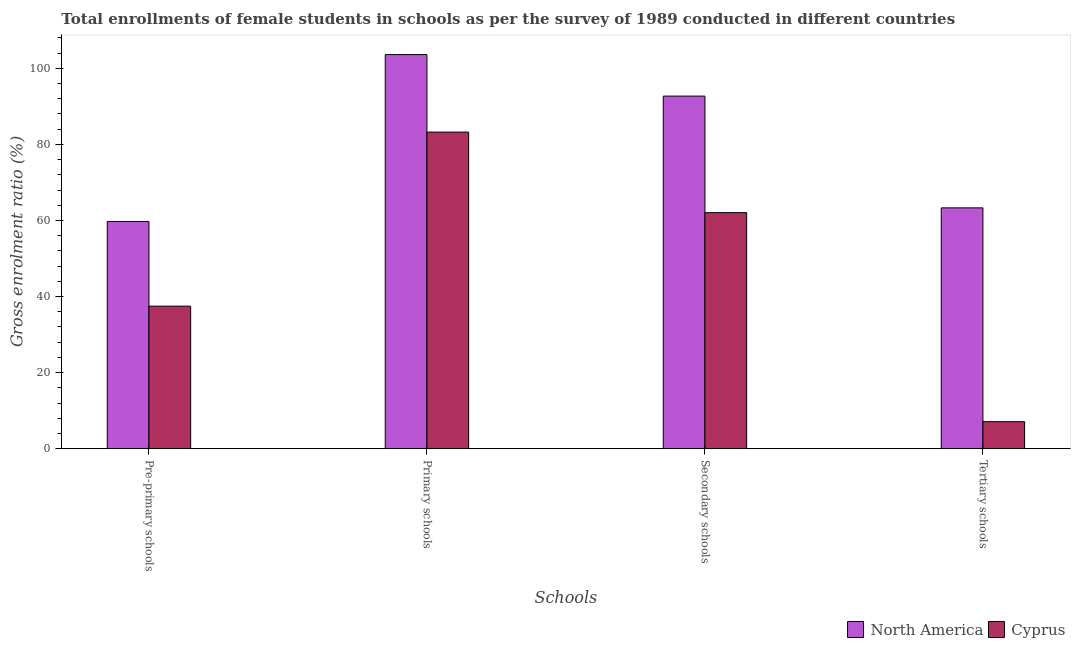How many groups of bars are there?
Ensure brevity in your answer.  4. Are the number of bars per tick equal to the number of legend labels?
Your response must be concise. Yes. How many bars are there on the 1st tick from the right?
Make the answer very short. 2. What is the label of the 3rd group of bars from the left?
Give a very brief answer. Secondary schools. What is the gross enrolment ratio(female) in pre-primary schools in Cyprus?
Your response must be concise. 37.47. Across all countries, what is the maximum gross enrolment ratio(female) in pre-primary schools?
Offer a terse response. 59.72. Across all countries, what is the minimum gross enrolment ratio(female) in tertiary schools?
Your response must be concise. 7.1. In which country was the gross enrolment ratio(female) in secondary schools minimum?
Offer a very short reply. Cyprus. What is the total gross enrolment ratio(female) in primary schools in the graph?
Provide a short and direct response. 186.83. What is the difference between the gross enrolment ratio(female) in primary schools in Cyprus and that in North America?
Offer a very short reply. -20.38. What is the difference between the gross enrolment ratio(female) in tertiary schools in Cyprus and the gross enrolment ratio(female) in secondary schools in North America?
Make the answer very short. -85.59. What is the average gross enrolment ratio(female) in secondary schools per country?
Make the answer very short. 77.37. What is the difference between the gross enrolment ratio(female) in secondary schools and gross enrolment ratio(female) in pre-primary schools in Cyprus?
Your answer should be compact. 24.58. In how many countries, is the gross enrolment ratio(female) in primary schools greater than 4 %?
Keep it short and to the point. 2. What is the ratio of the gross enrolment ratio(female) in secondary schools in Cyprus to that in North America?
Make the answer very short. 0.67. Is the gross enrolment ratio(female) in secondary schools in Cyprus less than that in North America?
Provide a short and direct response. Yes. Is the difference between the gross enrolment ratio(female) in pre-primary schools in Cyprus and North America greater than the difference between the gross enrolment ratio(female) in tertiary schools in Cyprus and North America?
Give a very brief answer. Yes. What is the difference between the highest and the second highest gross enrolment ratio(female) in secondary schools?
Provide a succinct answer. 30.64. What is the difference between the highest and the lowest gross enrolment ratio(female) in secondary schools?
Your response must be concise. 30.64. In how many countries, is the gross enrolment ratio(female) in secondary schools greater than the average gross enrolment ratio(female) in secondary schools taken over all countries?
Provide a succinct answer. 1. Is the sum of the gross enrolment ratio(female) in pre-primary schools in North America and Cyprus greater than the maximum gross enrolment ratio(female) in secondary schools across all countries?
Ensure brevity in your answer.  Yes. What does the 2nd bar from the left in Pre-primary schools represents?
Offer a terse response. Cyprus. Are all the bars in the graph horizontal?
Offer a terse response. No. What is the difference between two consecutive major ticks on the Y-axis?
Ensure brevity in your answer.  20. Does the graph contain any zero values?
Offer a terse response. No. Where does the legend appear in the graph?
Offer a very short reply. Bottom right. How many legend labels are there?
Your response must be concise. 2. What is the title of the graph?
Your response must be concise. Total enrollments of female students in schools as per the survey of 1989 conducted in different countries. Does "United States" appear as one of the legend labels in the graph?
Provide a short and direct response. No. What is the label or title of the X-axis?
Keep it short and to the point. Schools. What is the label or title of the Y-axis?
Keep it short and to the point. Gross enrolment ratio (%). What is the Gross enrolment ratio (%) of North America in Pre-primary schools?
Make the answer very short. 59.72. What is the Gross enrolment ratio (%) of Cyprus in Pre-primary schools?
Offer a terse response. 37.47. What is the Gross enrolment ratio (%) of North America in Primary schools?
Make the answer very short. 103.61. What is the Gross enrolment ratio (%) in Cyprus in Primary schools?
Keep it short and to the point. 83.23. What is the Gross enrolment ratio (%) of North America in Secondary schools?
Provide a succinct answer. 92.69. What is the Gross enrolment ratio (%) of Cyprus in Secondary schools?
Ensure brevity in your answer.  62.05. What is the Gross enrolment ratio (%) of North America in Tertiary schools?
Provide a short and direct response. 63.31. What is the Gross enrolment ratio (%) in Cyprus in Tertiary schools?
Make the answer very short. 7.1. Across all Schools, what is the maximum Gross enrolment ratio (%) of North America?
Offer a terse response. 103.61. Across all Schools, what is the maximum Gross enrolment ratio (%) of Cyprus?
Your answer should be compact. 83.23. Across all Schools, what is the minimum Gross enrolment ratio (%) of North America?
Your answer should be very brief. 59.72. Across all Schools, what is the minimum Gross enrolment ratio (%) of Cyprus?
Give a very brief answer. 7.1. What is the total Gross enrolment ratio (%) in North America in the graph?
Provide a succinct answer. 319.33. What is the total Gross enrolment ratio (%) in Cyprus in the graph?
Make the answer very short. 189.85. What is the difference between the Gross enrolment ratio (%) in North America in Pre-primary schools and that in Primary schools?
Ensure brevity in your answer.  -43.88. What is the difference between the Gross enrolment ratio (%) in Cyprus in Pre-primary schools and that in Primary schools?
Ensure brevity in your answer.  -45.76. What is the difference between the Gross enrolment ratio (%) of North America in Pre-primary schools and that in Secondary schools?
Offer a terse response. -32.97. What is the difference between the Gross enrolment ratio (%) of Cyprus in Pre-primary schools and that in Secondary schools?
Offer a terse response. -24.58. What is the difference between the Gross enrolment ratio (%) in North America in Pre-primary schools and that in Tertiary schools?
Ensure brevity in your answer.  -3.58. What is the difference between the Gross enrolment ratio (%) in Cyprus in Pre-primary schools and that in Tertiary schools?
Make the answer very short. 30.37. What is the difference between the Gross enrolment ratio (%) in North America in Primary schools and that in Secondary schools?
Offer a terse response. 10.92. What is the difference between the Gross enrolment ratio (%) of Cyprus in Primary schools and that in Secondary schools?
Offer a very short reply. 21.18. What is the difference between the Gross enrolment ratio (%) of North America in Primary schools and that in Tertiary schools?
Offer a terse response. 40.3. What is the difference between the Gross enrolment ratio (%) in Cyprus in Primary schools and that in Tertiary schools?
Keep it short and to the point. 76.13. What is the difference between the Gross enrolment ratio (%) in North America in Secondary schools and that in Tertiary schools?
Your answer should be very brief. 29.38. What is the difference between the Gross enrolment ratio (%) of Cyprus in Secondary schools and that in Tertiary schools?
Provide a short and direct response. 54.95. What is the difference between the Gross enrolment ratio (%) in North America in Pre-primary schools and the Gross enrolment ratio (%) in Cyprus in Primary schools?
Keep it short and to the point. -23.5. What is the difference between the Gross enrolment ratio (%) of North America in Pre-primary schools and the Gross enrolment ratio (%) of Cyprus in Secondary schools?
Offer a very short reply. -2.33. What is the difference between the Gross enrolment ratio (%) in North America in Pre-primary schools and the Gross enrolment ratio (%) in Cyprus in Tertiary schools?
Give a very brief answer. 52.62. What is the difference between the Gross enrolment ratio (%) in North America in Primary schools and the Gross enrolment ratio (%) in Cyprus in Secondary schools?
Your response must be concise. 41.56. What is the difference between the Gross enrolment ratio (%) in North America in Primary schools and the Gross enrolment ratio (%) in Cyprus in Tertiary schools?
Ensure brevity in your answer.  96.51. What is the difference between the Gross enrolment ratio (%) of North America in Secondary schools and the Gross enrolment ratio (%) of Cyprus in Tertiary schools?
Provide a succinct answer. 85.59. What is the average Gross enrolment ratio (%) in North America per Schools?
Give a very brief answer. 79.83. What is the average Gross enrolment ratio (%) in Cyprus per Schools?
Provide a succinct answer. 47.46. What is the difference between the Gross enrolment ratio (%) in North America and Gross enrolment ratio (%) in Cyprus in Pre-primary schools?
Provide a short and direct response. 22.25. What is the difference between the Gross enrolment ratio (%) of North America and Gross enrolment ratio (%) of Cyprus in Primary schools?
Ensure brevity in your answer.  20.38. What is the difference between the Gross enrolment ratio (%) in North America and Gross enrolment ratio (%) in Cyprus in Secondary schools?
Ensure brevity in your answer.  30.64. What is the difference between the Gross enrolment ratio (%) in North America and Gross enrolment ratio (%) in Cyprus in Tertiary schools?
Give a very brief answer. 56.21. What is the ratio of the Gross enrolment ratio (%) in North America in Pre-primary schools to that in Primary schools?
Provide a short and direct response. 0.58. What is the ratio of the Gross enrolment ratio (%) of Cyprus in Pre-primary schools to that in Primary schools?
Keep it short and to the point. 0.45. What is the ratio of the Gross enrolment ratio (%) of North America in Pre-primary schools to that in Secondary schools?
Make the answer very short. 0.64. What is the ratio of the Gross enrolment ratio (%) of Cyprus in Pre-primary schools to that in Secondary schools?
Your answer should be very brief. 0.6. What is the ratio of the Gross enrolment ratio (%) in North America in Pre-primary schools to that in Tertiary schools?
Provide a short and direct response. 0.94. What is the ratio of the Gross enrolment ratio (%) in Cyprus in Pre-primary schools to that in Tertiary schools?
Offer a terse response. 5.28. What is the ratio of the Gross enrolment ratio (%) in North America in Primary schools to that in Secondary schools?
Offer a very short reply. 1.12. What is the ratio of the Gross enrolment ratio (%) of Cyprus in Primary schools to that in Secondary schools?
Keep it short and to the point. 1.34. What is the ratio of the Gross enrolment ratio (%) of North America in Primary schools to that in Tertiary schools?
Ensure brevity in your answer.  1.64. What is the ratio of the Gross enrolment ratio (%) of Cyprus in Primary schools to that in Tertiary schools?
Keep it short and to the point. 11.72. What is the ratio of the Gross enrolment ratio (%) of North America in Secondary schools to that in Tertiary schools?
Your answer should be very brief. 1.46. What is the ratio of the Gross enrolment ratio (%) in Cyprus in Secondary schools to that in Tertiary schools?
Give a very brief answer. 8.74. What is the difference between the highest and the second highest Gross enrolment ratio (%) in North America?
Your answer should be compact. 10.92. What is the difference between the highest and the second highest Gross enrolment ratio (%) of Cyprus?
Offer a very short reply. 21.18. What is the difference between the highest and the lowest Gross enrolment ratio (%) of North America?
Offer a terse response. 43.88. What is the difference between the highest and the lowest Gross enrolment ratio (%) in Cyprus?
Make the answer very short. 76.13. 